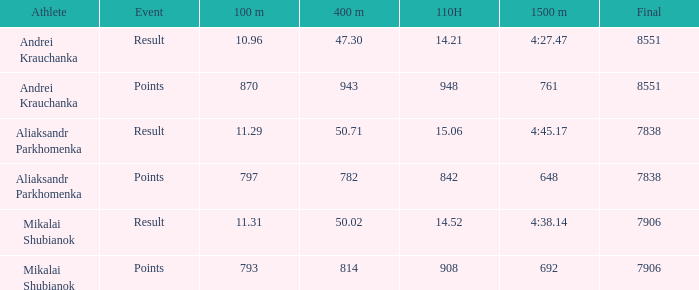What was the 110H that the 1500m was 692 and the final was more than 7906? 0.0. 